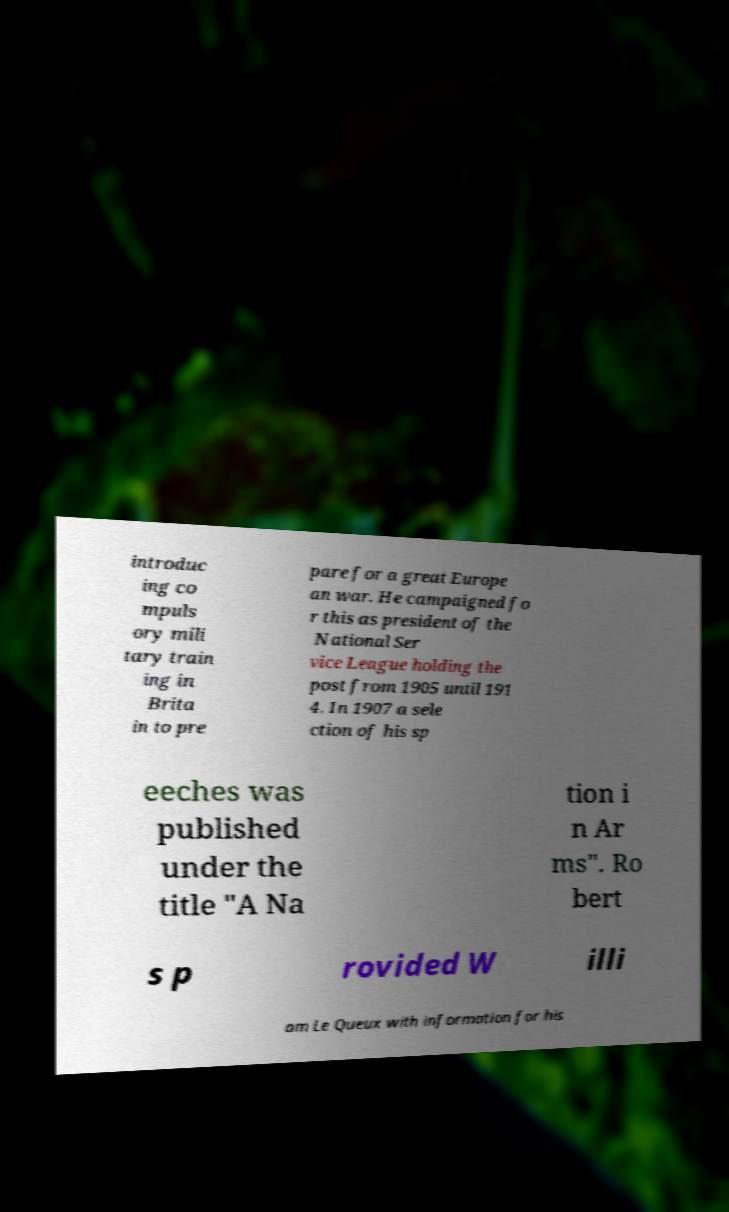Please read and relay the text visible in this image. What does it say? introduc ing co mpuls ory mili tary train ing in Brita in to pre pare for a great Europe an war. He campaigned fo r this as president of the National Ser vice League holding the post from 1905 until 191 4. In 1907 a sele ction of his sp eeches was published under the title "A Na tion i n Ar ms". Ro bert s p rovided W illi am Le Queux with information for his 